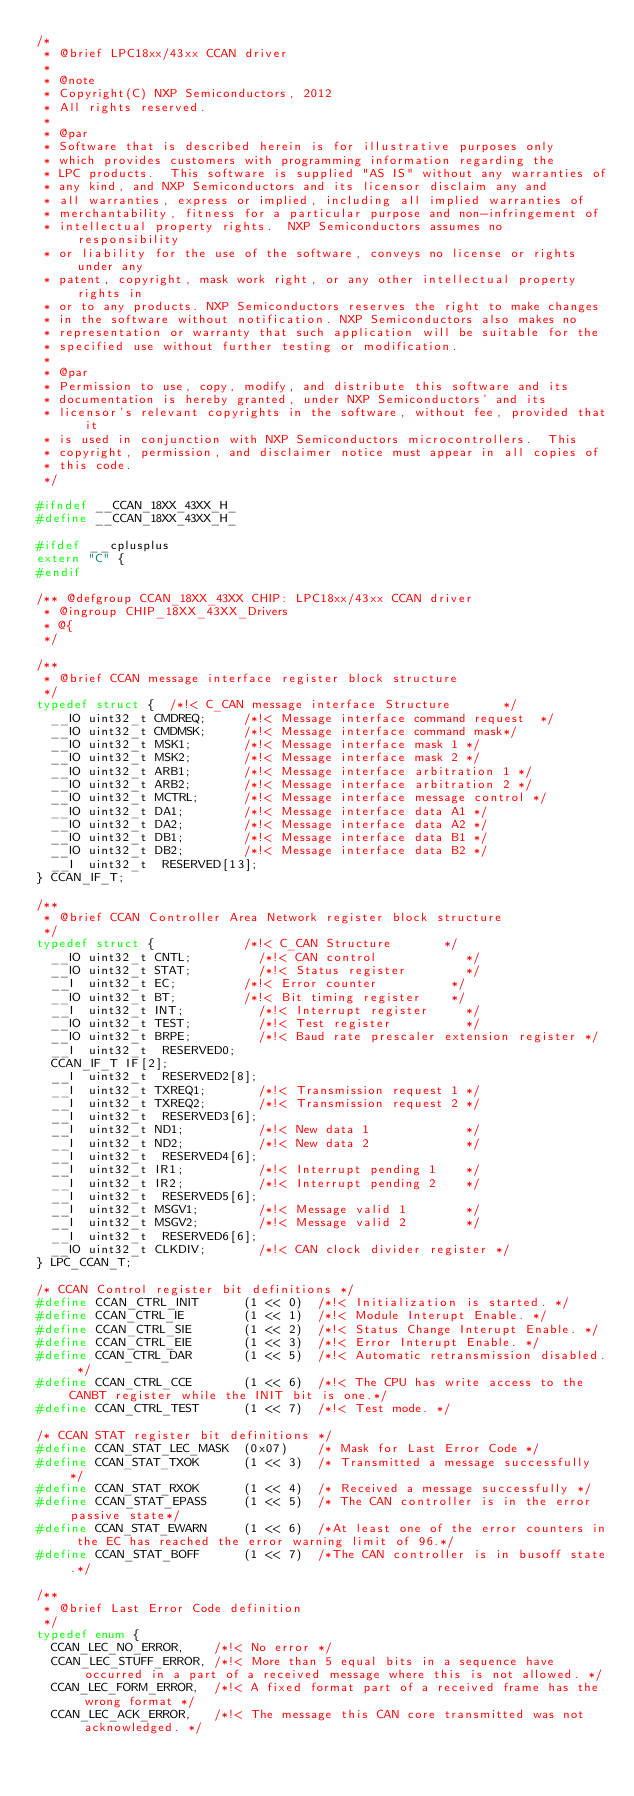<code> <loc_0><loc_0><loc_500><loc_500><_C_>/*
 * @brief LPC18xx/43xx CCAN driver
 *
 * @note
 * Copyright(C) NXP Semiconductors, 2012
 * All rights reserved.
 *
 * @par
 * Software that is described herein is for illustrative purposes only
 * which provides customers with programming information regarding the
 * LPC products.  This software is supplied "AS IS" without any warranties of
 * any kind, and NXP Semiconductors and its licensor disclaim any and
 * all warranties, express or implied, including all implied warranties of
 * merchantability, fitness for a particular purpose and non-infringement of
 * intellectual property rights.  NXP Semiconductors assumes no responsibility
 * or liability for the use of the software, conveys no license or rights under any
 * patent, copyright, mask work right, or any other intellectual property rights in
 * or to any products. NXP Semiconductors reserves the right to make changes
 * in the software without notification. NXP Semiconductors also makes no
 * representation or warranty that such application will be suitable for the
 * specified use without further testing or modification.
 *
 * @par
 * Permission to use, copy, modify, and distribute this software and its
 * documentation is hereby granted, under NXP Semiconductors' and its
 * licensor's relevant copyrights in the software, without fee, provided that it
 * is used in conjunction with NXP Semiconductors microcontrollers.  This
 * copyright, permission, and disclaimer notice must appear in all copies of
 * this code.
 */

#ifndef __CCAN_18XX_43XX_H_
#define __CCAN_18XX_43XX_H_

#ifdef __cplusplus
extern "C" {
#endif

/** @defgroup CCAN_18XX_43XX CHIP: LPC18xx/43xx CCAN driver
 * @ingroup CHIP_18XX_43XX_Drivers
 * @{
 */

/**
 * @brief CCAN message interface register block structure
 */
typedef struct {	/*!< C_CAN message interface Structure       */
	__IO uint32_t CMDREQ;			/*!< Message interface command request  */
	__IO uint32_t CMDMSK;			/*!< Message interface command mask*/
	__IO uint32_t MSK1;				/*!< Message interface mask 1 */
	__IO uint32_t MSK2;				/*!< Message interface mask 2 */
	__IO uint32_t ARB1;				/*!< Message interface arbitration 1 */
	__IO uint32_t ARB2;				/*!< Message interface arbitration 2 */
	__IO uint32_t MCTRL;			/*!< Message interface message control */
	__IO uint32_t DA1;				/*!< Message interface data A1 */
	__IO uint32_t DA2;				/*!< Message interface data A2 */
	__IO uint32_t DB1;				/*!< Message interface data B1 */
	__IO uint32_t DB2;				/*!< Message interface data B2 */
	__I  uint32_t  RESERVED[13];
} CCAN_IF_T;

/**
 * @brief CCAN Controller Area Network register block structure
 */
typedef struct {						/*!< C_CAN Structure       */
	__IO uint32_t CNTL;					/*!< CAN control            */
	__IO uint32_t STAT;					/*!< Status register        */
	__I  uint32_t EC;					/*!< Error counter          */
	__IO uint32_t BT;					/*!< Bit timing register    */
	__I  uint32_t INT;					/*!< Interrupt register     */
	__IO uint32_t TEST;					/*!< Test register          */
	__IO uint32_t BRPE;					/*!< Baud rate prescaler extension register */
	__I  uint32_t  RESERVED0;
	CCAN_IF_T IF[2];
	__I  uint32_t  RESERVED2[8];
	__I  uint32_t TXREQ1;				/*!< Transmission request 1 */
	__I  uint32_t TXREQ2;				/*!< Transmission request 2 */
	__I  uint32_t  RESERVED3[6];
	__I  uint32_t ND1;					/*!< New data 1             */
	__I  uint32_t ND2;					/*!< New data 2             */
	__I  uint32_t  RESERVED4[6];
	__I  uint32_t IR1;					/*!< Interrupt pending 1    */
	__I  uint32_t IR2;					/*!< Interrupt pending 2    */
	__I  uint32_t  RESERVED5[6];
	__I  uint32_t MSGV1;				/*!< Message valid 1        */
	__I  uint32_t MSGV2;				/*!< Message valid 2        */
	__I  uint32_t  RESERVED6[6];
	__IO uint32_t CLKDIV;				/*!< CAN clock divider register */
} LPC_CCAN_T;

/* CCAN Control register bit definitions */
#define CCAN_CTRL_INIT      (1 << 0)	/*!< Initialization is started. */
#define CCAN_CTRL_IE        (1 << 1)	/*!< Module Interupt Enable. */
#define CCAN_CTRL_SIE       (1 << 2)	/*!< Status Change Interupt Enable. */
#define CCAN_CTRL_EIE       (1 << 3)	/*!< Error Interupt Enable. */
#define CCAN_CTRL_DAR       (1 << 5)	/*!< Automatic retransmission disabled. */
#define CCAN_CTRL_CCE       (1 << 6)	/*!< The CPU has write access to the CANBT register while the INIT bit is one.*/
#define CCAN_CTRL_TEST      (1 << 7)	/*!< Test mode. */

/* CCAN STAT register bit definitions */
#define CCAN_STAT_LEC_MASK  (0x07)		/* Mask for Last Error Code */
#define CCAN_STAT_TXOK      (1 << 3)	/* Transmitted a message successfully */
#define CCAN_STAT_RXOK      (1 << 4)	/* Received a message successfully */
#define CCAN_STAT_EPASS     (1 << 5)	/* The CAN controller is in the error passive state*/
#define CCAN_STAT_EWARN     (1 << 6)	/*At least one of the error counters in the EC has reached the error warning limit of 96.*/
#define CCAN_STAT_BOFF      (1 << 7)	/*The CAN controller is in busoff state.*/

/**
 * @brief Last Error Code definition
 */
typedef enum {
	CCAN_LEC_NO_ERROR,		/*!< No error */
	CCAN_LEC_STUFF_ERROR,	/*!< More than 5 equal bits in a sequence have occurred in a part of a received message where this is not allowed. */
	CCAN_LEC_FORM_ERROR,	/*!< A fixed format part of a received frame has the wrong format */
	CCAN_LEC_ACK_ERROR,		/*!< The message this CAN core transmitted was not acknowledged. */</code> 